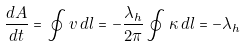Convert formula to latex. <formula><loc_0><loc_0><loc_500><loc_500>\frac { d A } { d t } = \oint v \, d l = - \frac { \lambda _ { h } } { 2 \pi } \oint \kappa \, d l = - \lambda _ { h }</formula> 